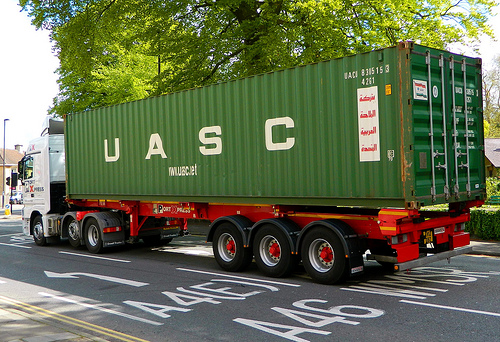Is there a truck in the scene that is red? No, there is no red truck in the scene. 